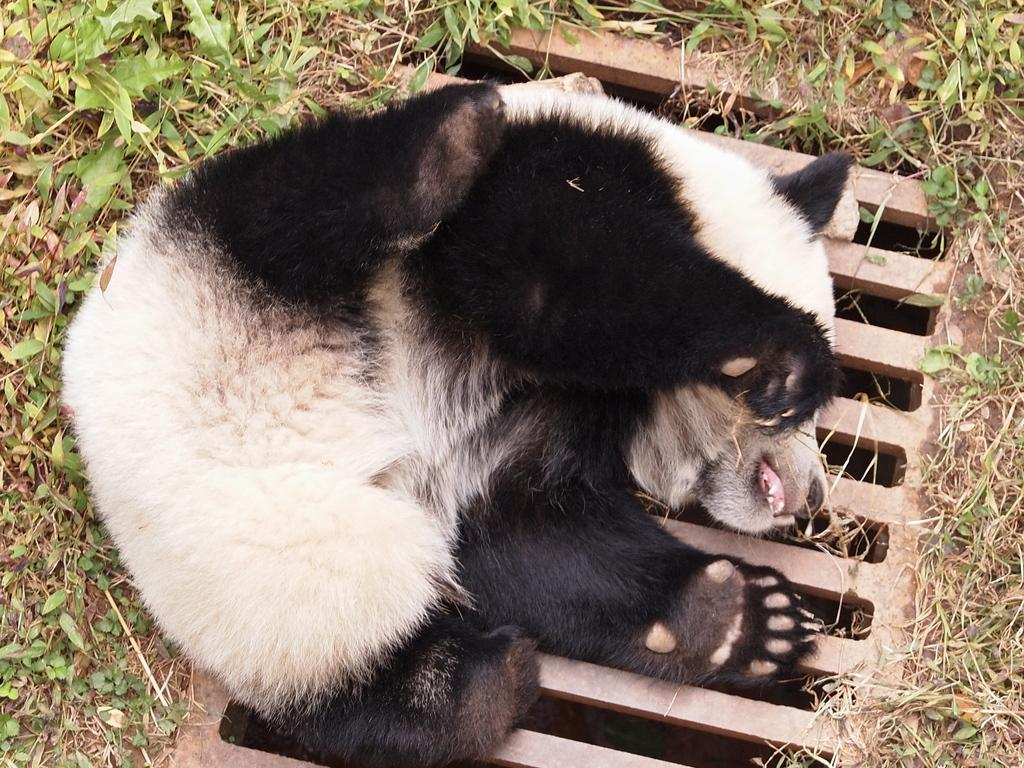What type of animal can be seen in the image? There is an animal in the image, but its specific type cannot be determined from the provided facts. What colors are present on the animal in the image? The animal is black and cream in color. Where is the animal located in the image? The animal is on the ground in the image. What type of structure is visible in the image? There is a manhole grill visible in the image. What type of vegetation is present in the image? There are trees and grass in the image. What degree does the table have in the image? There is no table present in the image, so it is not possible to determine the degree of any table. 